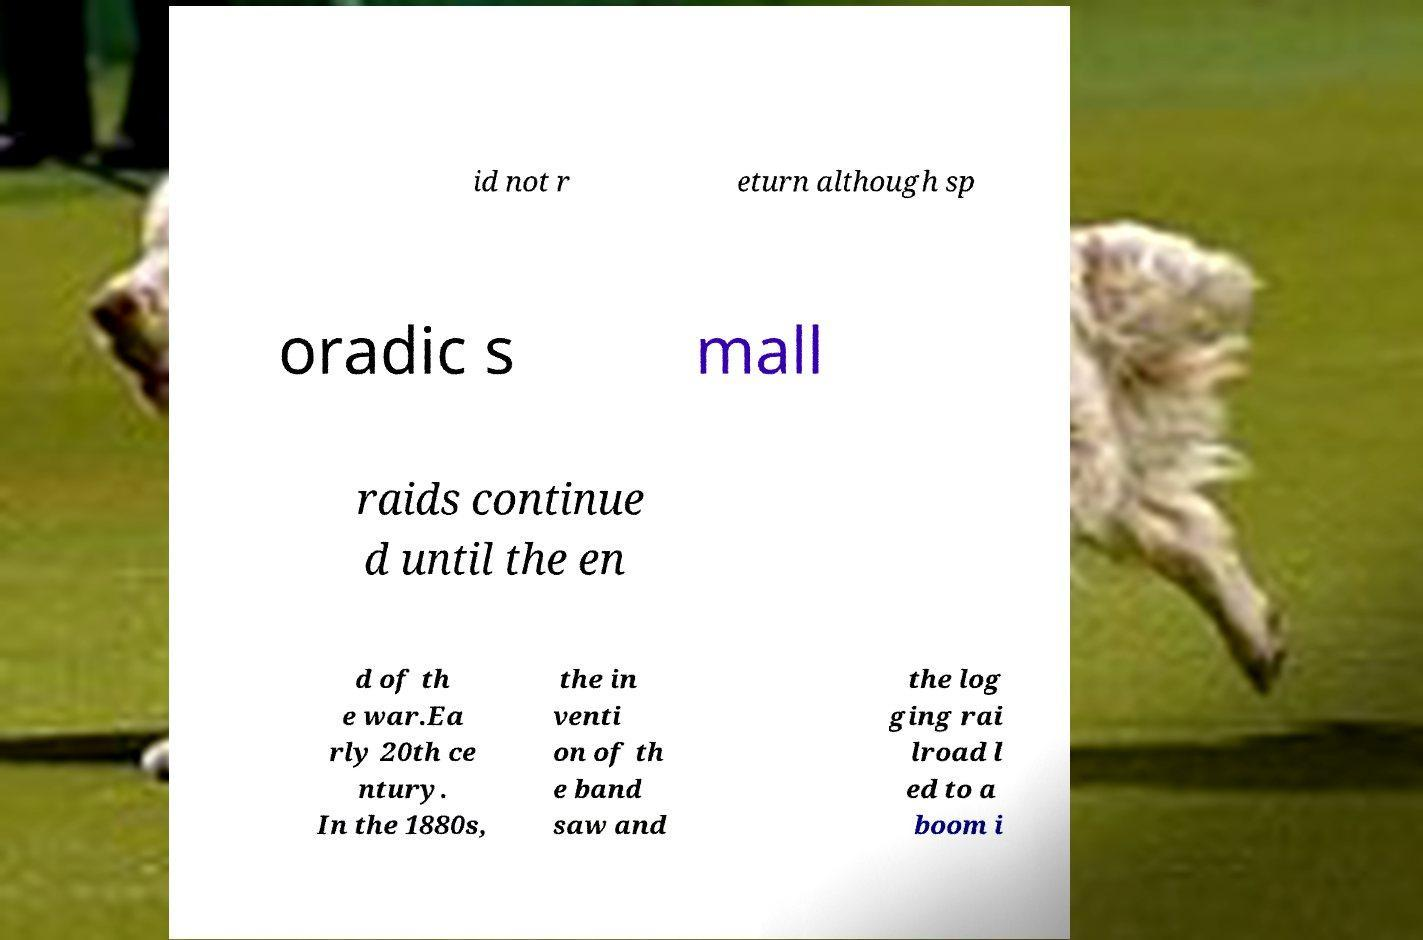Please read and relay the text visible in this image. What does it say? id not r eturn although sp oradic s mall raids continue d until the en d of th e war.Ea rly 20th ce ntury. In the 1880s, the in venti on of th e band saw and the log ging rai lroad l ed to a boom i 